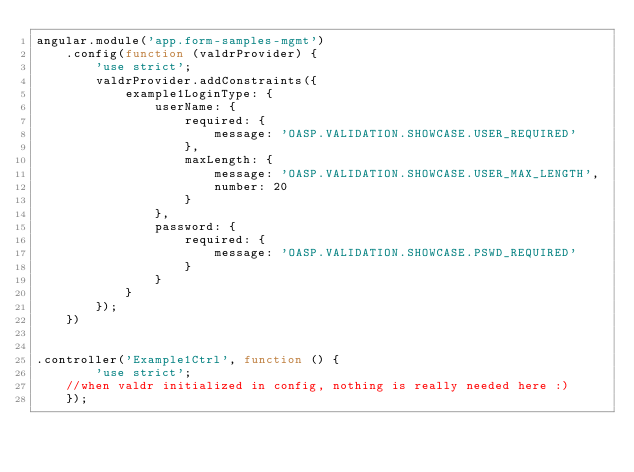Convert code to text. <code><loc_0><loc_0><loc_500><loc_500><_JavaScript_>angular.module('app.form-samples-mgmt')
    .config(function (valdrProvider) {
        'use strict';
        valdrProvider.addConstraints({
            example1LoginType: {
                userName: {
                    required: {
                        message: 'OASP.VALIDATION.SHOWCASE.USER_REQUIRED'
                    },
                    maxLength: {
                        message: 'OASP.VALIDATION.SHOWCASE.USER_MAX_LENGTH',
                        number: 20
                    }
                },
                password: {
                    required: {
                        message: 'OASP.VALIDATION.SHOWCASE.PSWD_REQUIRED'
                    }
                }
            }
        });
    })


.controller('Example1Ctrl', function () {
        'use strict';
    //when valdr initialized in config, nothing is really needed here :)
    });
</code> 